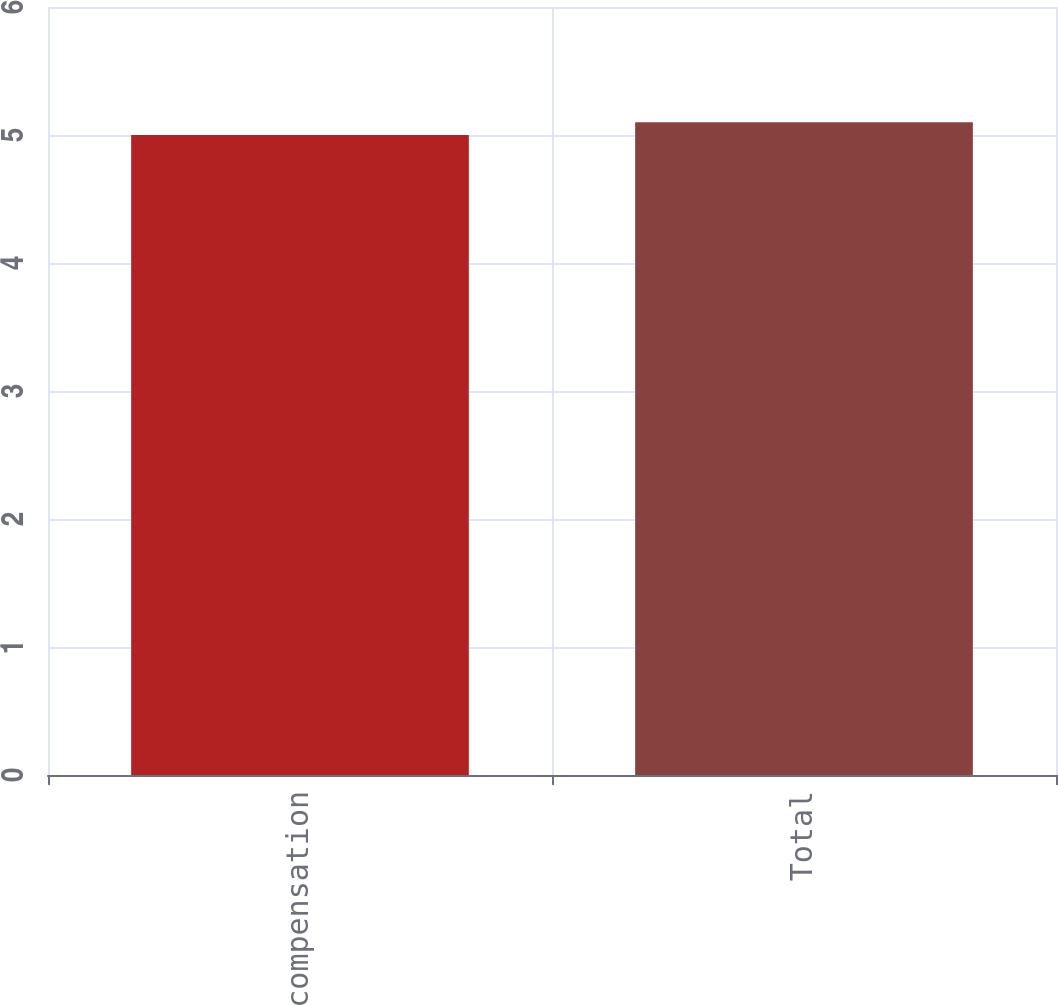Convert chart to OTSL. <chart><loc_0><loc_0><loc_500><loc_500><bar_chart><fcel>Equity compensation<fcel>Total<nl><fcel>5<fcel>5.1<nl></chart> 